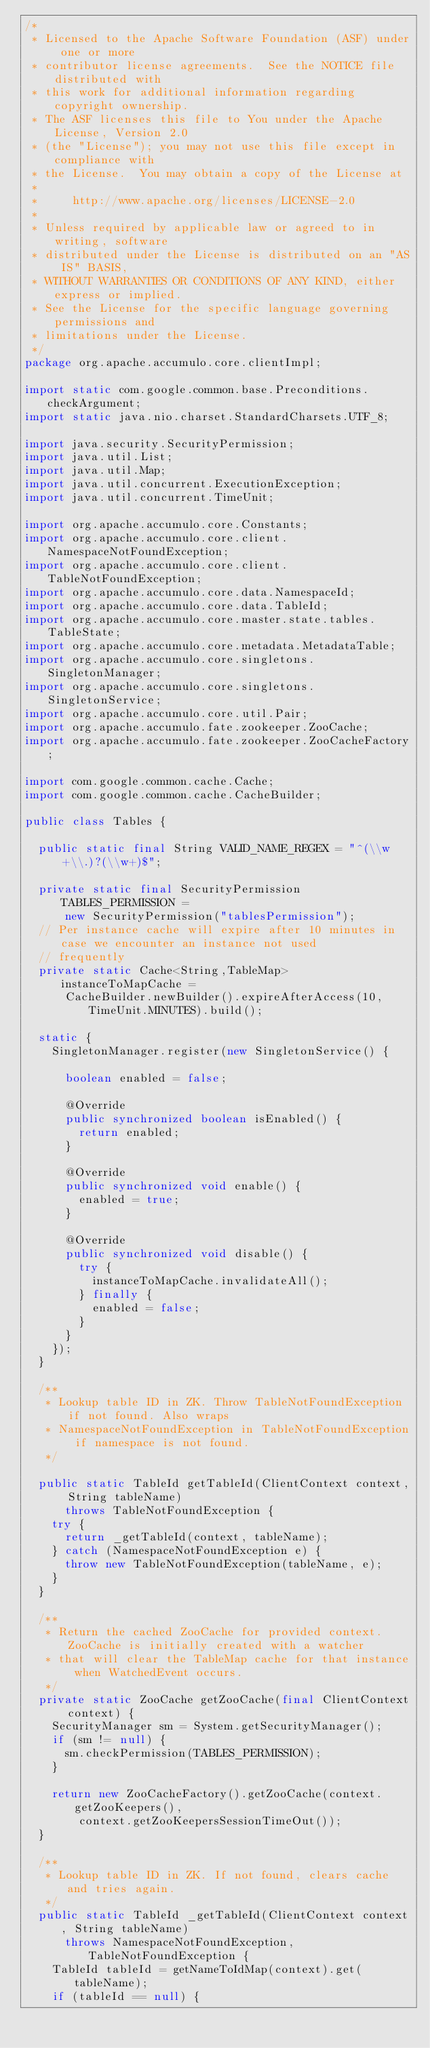<code> <loc_0><loc_0><loc_500><loc_500><_Java_>/*
 * Licensed to the Apache Software Foundation (ASF) under one or more
 * contributor license agreements.  See the NOTICE file distributed with
 * this work for additional information regarding copyright ownership.
 * The ASF licenses this file to You under the Apache License, Version 2.0
 * (the "License"); you may not use this file except in compliance with
 * the License.  You may obtain a copy of the License at
 *
 *     http://www.apache.org/licenses/LICENSE-2.0
 *
 * Unless required by applicable law or agreed to in writing, software
 * distributed under the License is distributed on an "AS IS" BASIS,
 * WITHOUT WARRANTIES OR CONDITIONS OF ANY KIND, either express or implied.
 * See the License for the specific language governing permissions and
 * limitations under the License.
 */
package org.apache.accumulo.core.clientImpl;

import static com.google.common.base.Preconditions.checkArgument;
import static java.nio.charset.StandardCharsets.UTF_8;

import java.security.SecurityPermission;
import java.util.List;
import java.util.Map;
import java.util.concurrent.ExecutionException;
import java.util.concurrent.TimeUnit;

import org.apache.accumulo.core.Constants;
import org.apache.accumulo.core.client.NamespaceNotFoundException;
import org.apache.accumulo.core.client.TableNotFoundException;
import org.apache.accumulo.core.data.NamespaceId;
import org.apache.accumulo.core.data.TableId;
import org.apache.accumulo.core.master.state.tables.TableState;
import org.apache.accumulo.core.metadata.MetadataTable;
import org.apache.accumulo.core.singletons.SingletonManager;
import org.apache.accumulo.core.singletons.SingletonService;
import org.apache.accumulo.core.util.Pair;
import org.apache.accumulo.fate.zookeeper.ZooCache;
import org.apache.accumulo.fate.zookeeper.ZooCacheFactory;

import com.google.common.cache.Cache;
import com.google.common.cache.CacheBuilder;

public class Tables {

  public static final String VALID_NAME_REGEX = "^(\\w+\\.)?(\\w+)$";

  private static final SecurityPermission TABLES_PERMISSION =
      new SecurityPermission("tablesPermission");
  // Per instance cache will expire after 10 minutes in case we encounter an instance not used
  // frequently
  private static Cache<String,TableMap> instanceToMapCache =
      CacheBuilder.newBuilder().expireAfterAccess(10, TimeUnit.MINUTES).build();

  static {
    SingletonManager.register(new SingletonService() {

      boolean enabled = false;

      @Override
      public synchronized boolean isEnabled() {
        return enabled;
      }

      @Override
      public synchronized void enable() {
        enabled = true;
      }

      @Override
      public synchronized void disable() {
        try {
          instanceToMapCache.invalidateAll();
        } finally {
          enabled = false;
        }
      }
    });
  }

  /**
   * Lookup table ID in ZK. Throw TableNotFoundException if not found. Also wraps
   * NamespaceNotFoundException in TableNotFoundException if namespace is not found.
   */

  public static TableId getTableId(ClientContext context, String tableName)
      throws TableNotFoundException {
    try {
      return _getTableId(context, tableName);
    } catch (NamespaceNotFoundException e) {
      throw new TableNotFoundException(tableName, e);
    }
  }

  /**
   * Return the cached ZooCache for provided context. ZooCache is initially created with a watcher
   * that will clear the TableMap cache for that instance when WatchedEvent occurs.
   */
  private static ZooCache getZooCache(final ClientContext context) {
    SecurityManager sm = System.getSecurityManager();
    if (sm != null) {
      sm.checkPermission(TABLES_PERMISSION);
    }

    return new ZooCacheFactory().getZooCache(context.getZooKeepers(),
        context.getZooKeepersSessionTimeOut());
  }

  /**
   * Lookup table ID in ZK. If not found, clears cache and tries again.
   */
  public static TableId _getTableId(ClientContext context, String tableName)
      throws NamespaceNotFoundException, TableNotFoundException {
    TableId tableId = getNameToIdMap(context).get(tableName);
    if (tableId == null) {</code> 